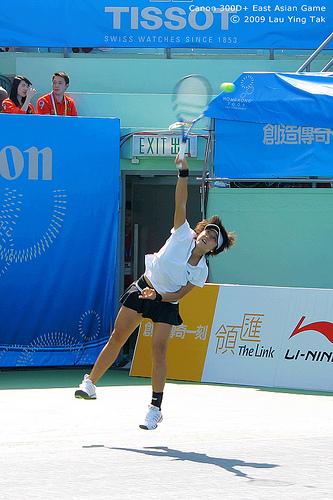What year is on the picture?
Concise answer only. 2009. What language are the ads written in?
Write a very short answer. Chinese. Is the lady touching the ground?
Keep it brief. No. 